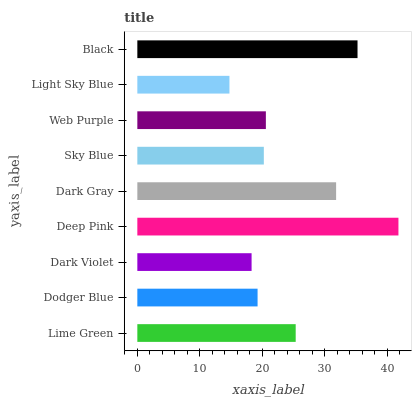Is Light Sky Blue the minimum?
Answer yes or no. Yes. Is Deep Pink the maximum?
Answer yes or no. Yes. Is Dodger Blue the minimum?
Answer yes or no. No. Is Dodger Blue the maximum?
Answer yes or no. No. Is Lime Green greater than Dodger Blue?
Answer yes or no. Yes. Is Dodger Blue less than Lime Green?
Answer yes or no. Yes. Is Dodger Blue greater than Lime Green?
Answer yes or no. No. Is Lime Green less than Dodger Blue?
Answer yes or no. No. Is Web Purple the high median?
Answer yes or no. Yes. Is Web Purple the low median?
Answer yes or no. Yes. Is Black the high median?
Answer yes or no. No. Is Dark Violet the low median?
Answer yes or no. No. 